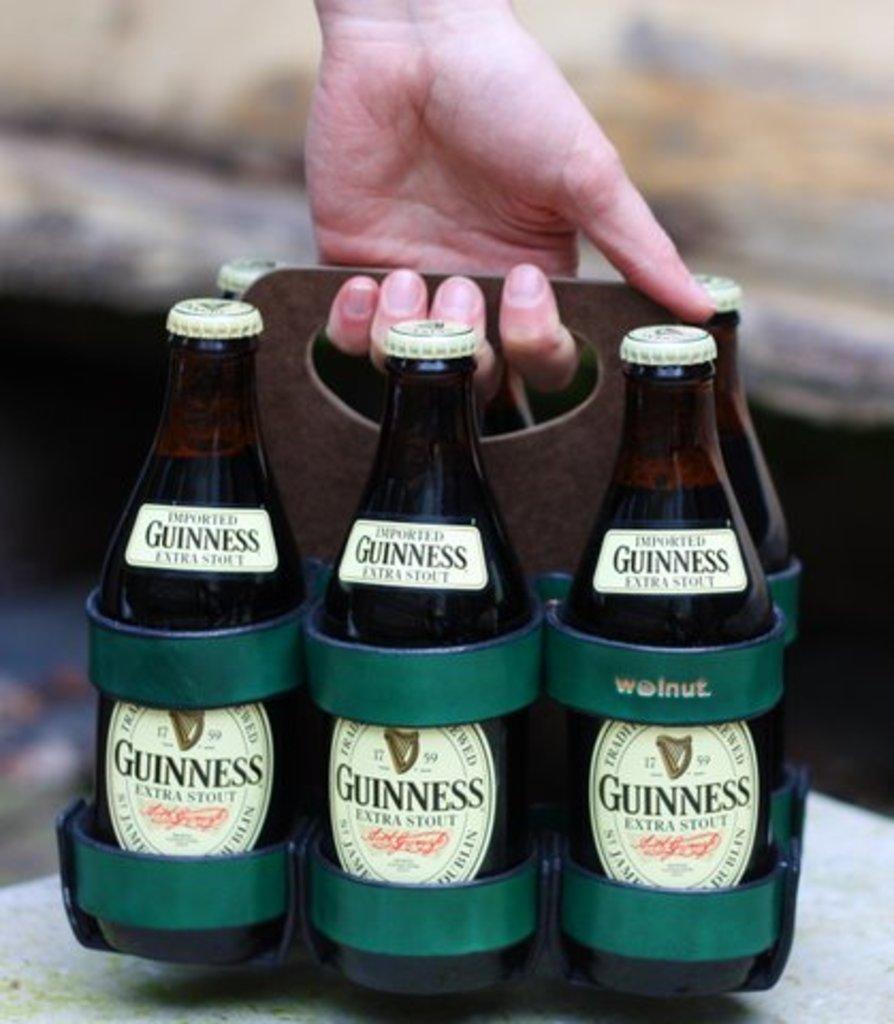Could you give a brief overview of what you see in this image? In this Image I see a person's hand who is holding bottles and I see stickers on the bottles on which there are few words on it. 